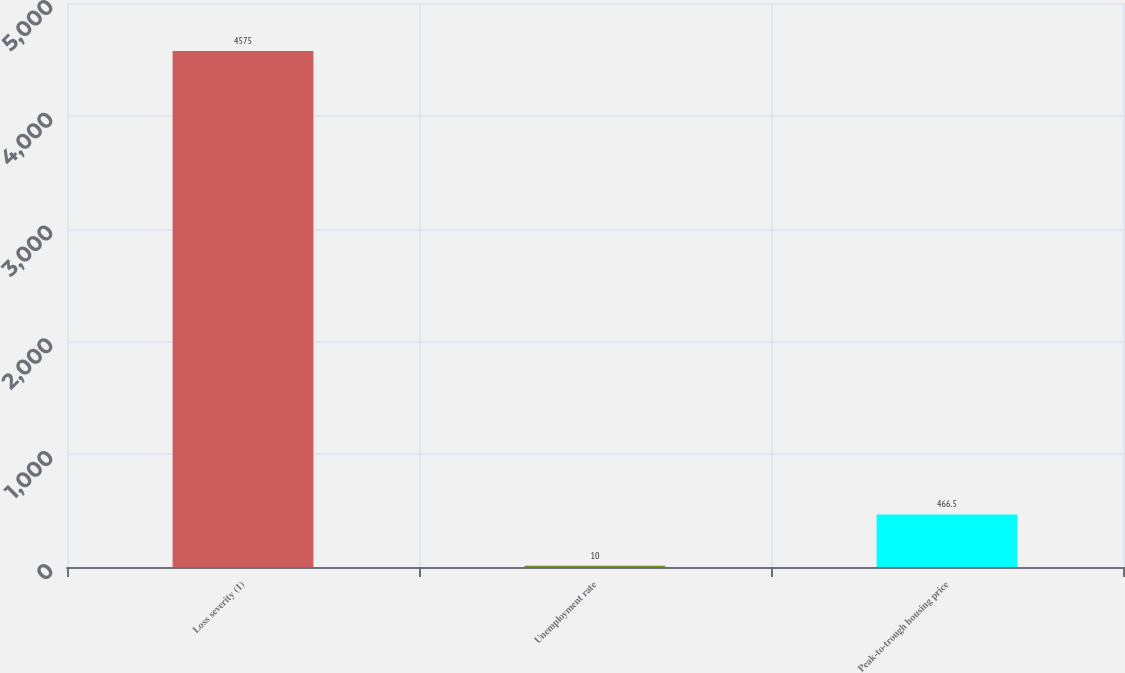Convert chart. <chart><loc_0><loc_0><loc_500><loc_500><bar_chart><fcel>Loss severity (1)<fcel>Unemployment rate<fcel>Peak-to-trough housing price<nl><fcel>4575<fcel>10<fcel>466.5<nl></chart> 